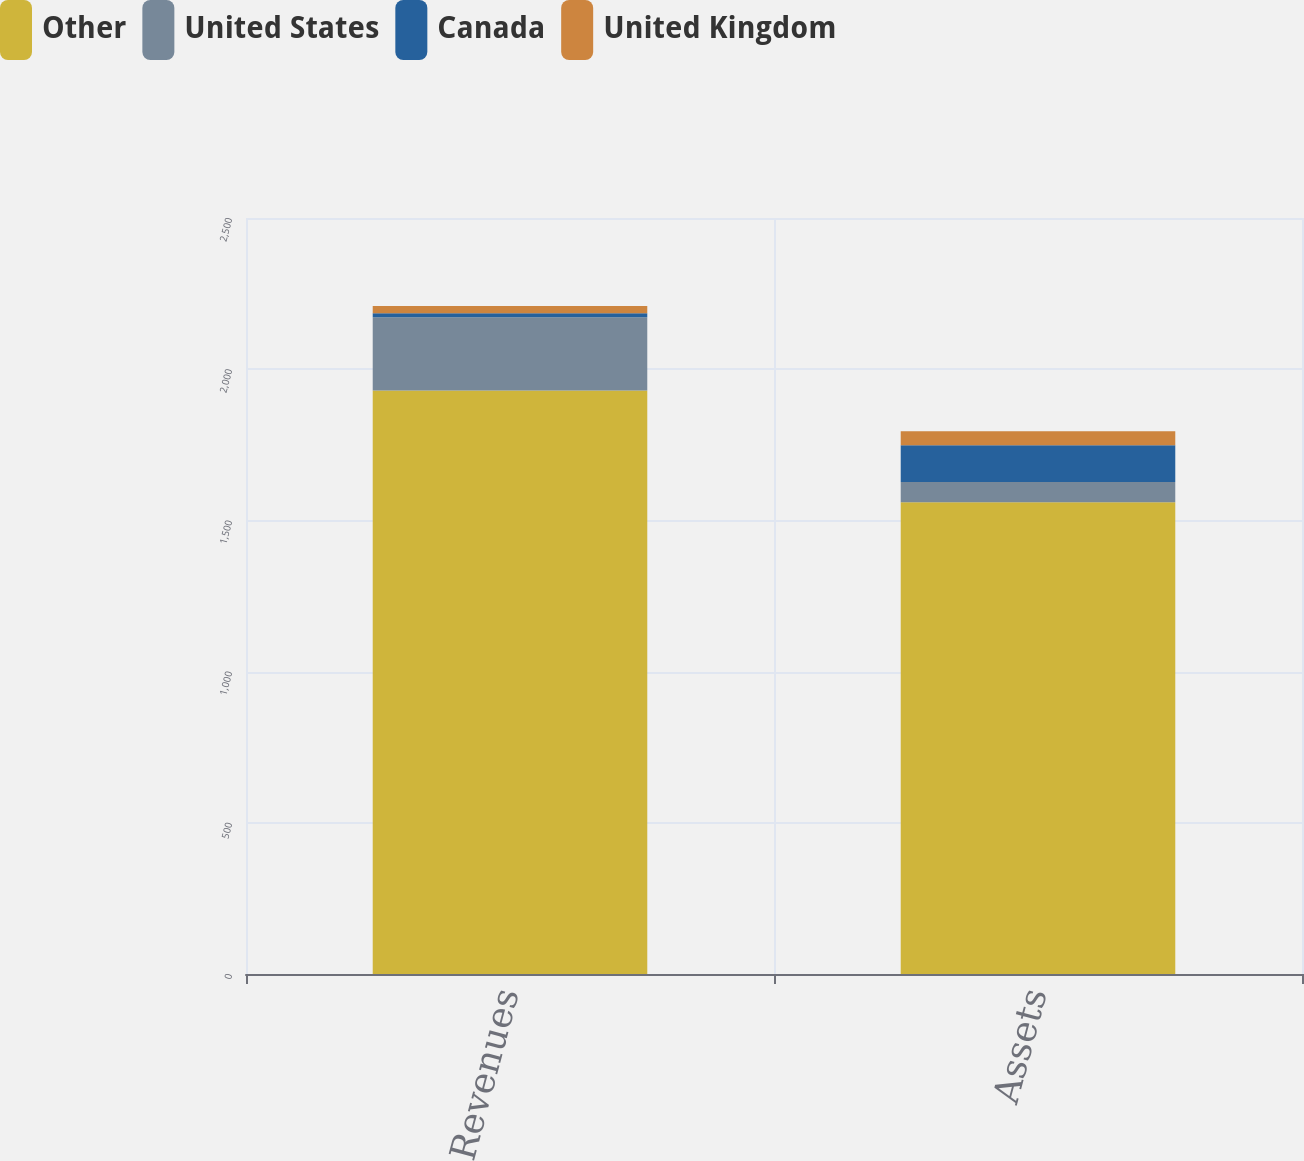<chart> <loc_0><loc_0><loc_500><loc_500><stacked_bar_chart><ecel><fcel>Revenues<fcel>Assets<nl><fcel>Other<fcel>1929.6<fcel>1560.1<nl><fcel>United States<fcel>241.9<fcel>67<nl><fcel>Canada<fcel>13.9<fcel>121.3<nl><fcel>United Kingdom<fcel>23.8<fcel>46<nl></chart> 